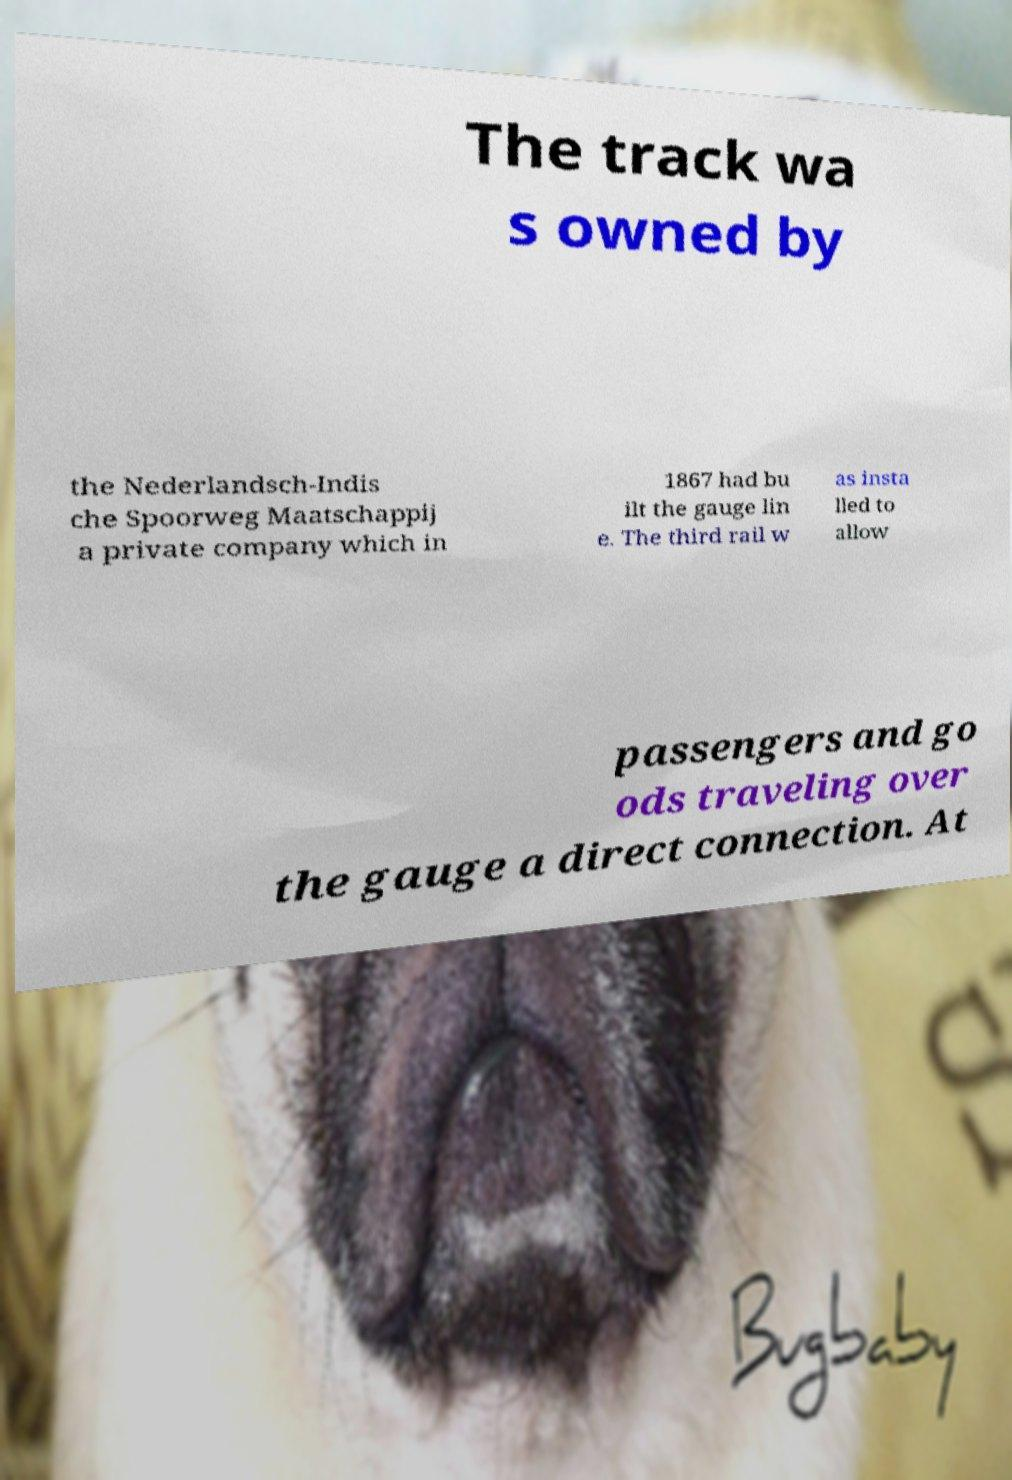Please read and relay the text visible in this image. What does it say? The track wa s owned by the Nederlandsch-Indis che Spoorweg Maatschappij a private company which in 1867 had bu ilt the gauge lin e. The third rail w as insta lled to allow passengers and go ods traveling over the gauge a direct connection. At 